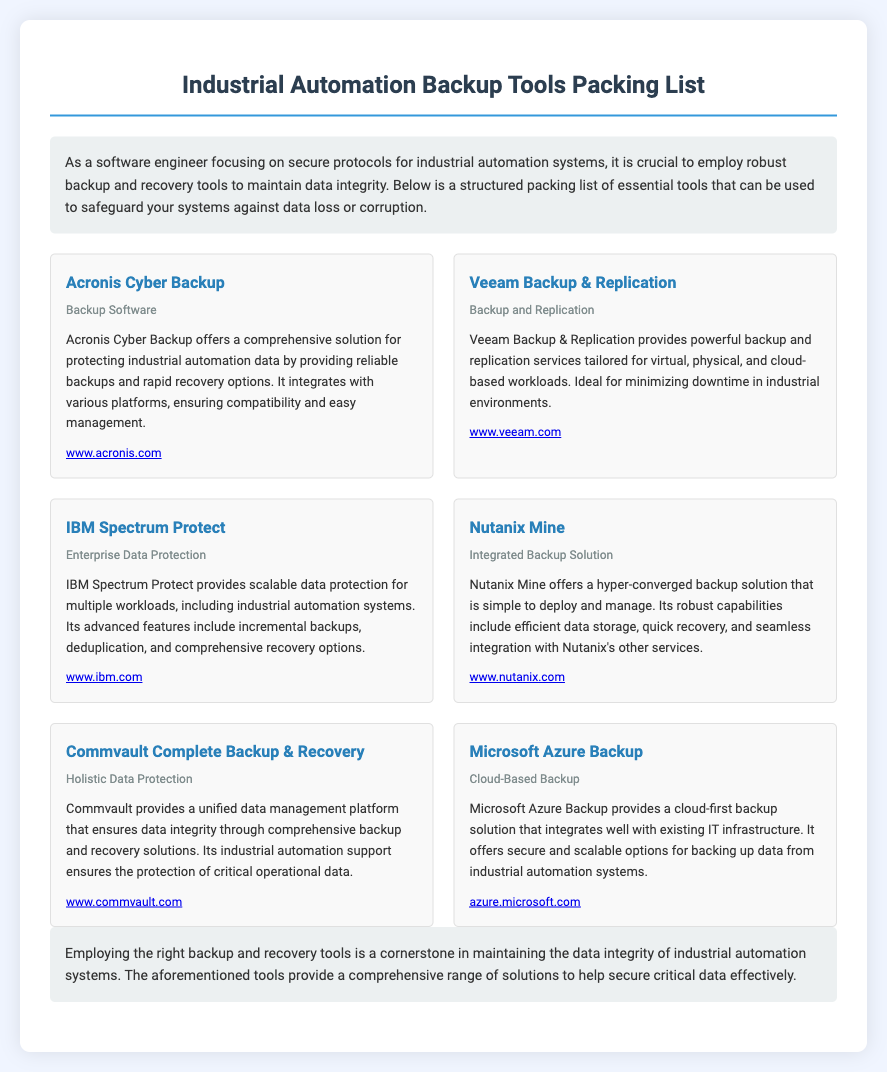what is the title of the document? The title appears at the top of the rendered document, clearly stated as "Industrial Automation Backup Tools Packing List."
Answer: Industrial Automation Backup Tools Packing List how many backup tools are listed? The document features a total of six backup and recovery tools, as referenced in the tool list section.
Answer: 6 what is the category of Acronis Cyber Backup? The category is mentioned within the tool item description for Acronis Cyber Backup.
Answer: Backup Software which tool provides a cloud-first backup solution? The tool that offers this solution is specified in the description of Microsoft Azure Backup.
Answer: Microsoft Azure Backup what is the primary feature of Commvault Complete Backup & Recovery? The document states that Commvault provides a unified data management platform ensuring data integrity through comprehensive solutions.
Answer: Unified data management platform which backup tool is integrated with Microsoft Azure? The document mentions the tool associated with cloud services and integration with existing infrastructure.
Answer: Microsoft Azure Backup name one feature of IBM Spectrum Protect. Features are listed in the tool description; one of them is mentioned specifically.
Answer: Incremental backups which tool is ideal for minimizing downtime in industrial environments? The description of the tool tailored to minimize downtime explicitly mentions its adaptability to such environments.
Answer: Veeam Backup & Replication 